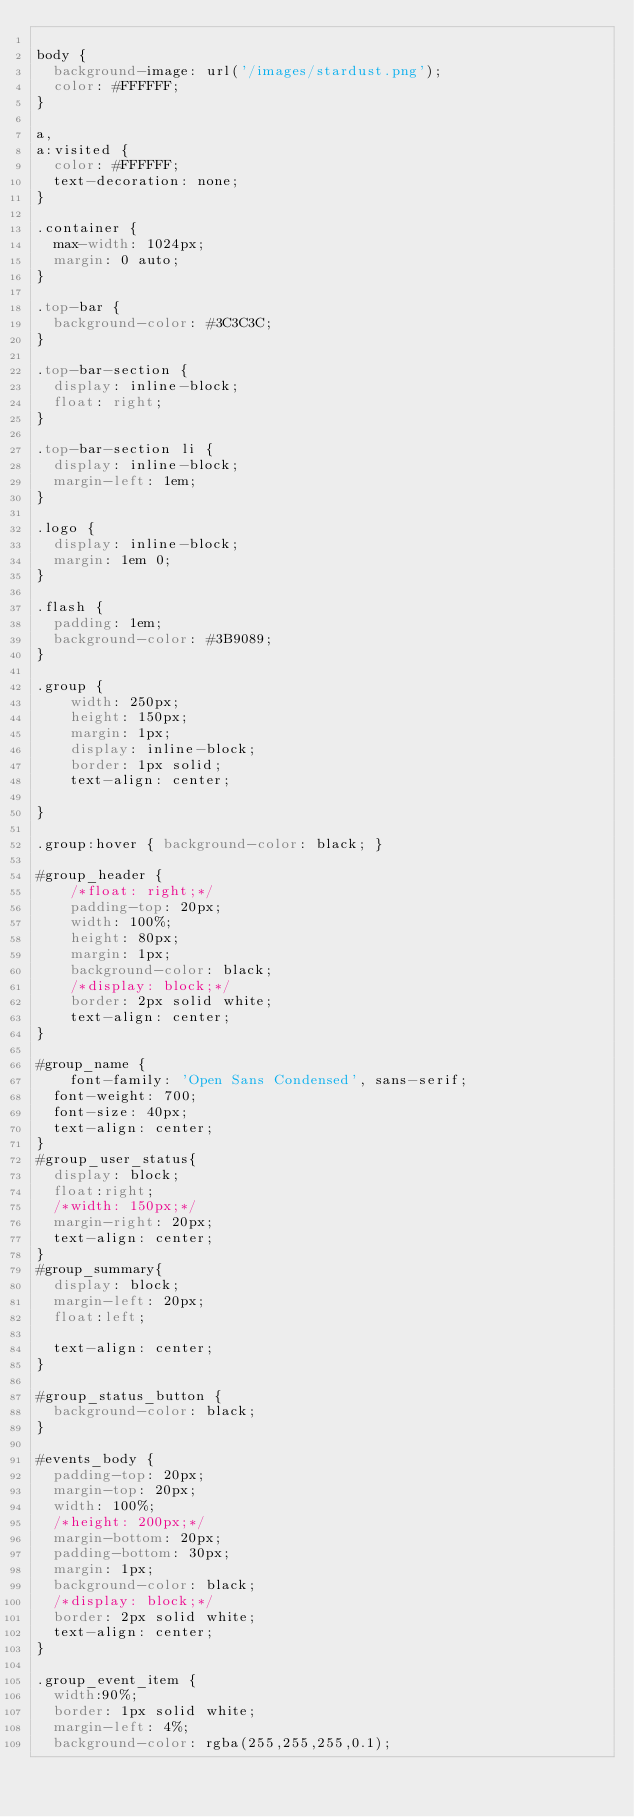<code> <loc_0><loc_0><loc_500><loc_500><_CSS_>
body {
  background-image: url('/images/stardust.png');
  color: #FFFFFF;
}

a,
a:visited {
  color: #FFFFFF;
  text-decoration: none;
}

.container {
  max-width: 1024px;
  margin: 0 auto;
}

.top-bar {
  background-color: #3C3C3C;
}

.top-bar-section {
  display: inline-block;
  float: right;
}

.top-bar-section li {
  display: inline-block;
  margin-left: 1em;
}

.logo {
  display: inline-block;
  margin: 1em 0;
}

.flash {
  padding: 1em;
  background-color: #3B9089;
}

.group {
    width: 250px;
    height: 150px;
    margin: 1px;
    display: inline-block;
    border: 1px solid;
    text-align: center;

}

.group:hover { background-color: black; }

#group_header {
    /*float: right;*/
    padding-top: 20px;
    width: 100%;
    height: 80px;
    margin: 1px;
    background-color: black;
    /*display: block;*/
    border: 2px solid white;
    text-align: center;
}

#group_name {
    font-family: 'Open Sans Condensed', sans-serif;
  font-weight: 700;
  font-size: 40px;
  text-align: center;
}
#group_user_status{
  display: block;
  float:right;
  /*width: 150px;*/
  margin-right: 20px;
  text-align: center;
}
#group_summary{
  display: block;
  margin-left: 20px;
  float:left;

  text-align: center;
}

#group_status_button {
  background-color: black;
}

#events_body {
  padding-top: 20px;
  margin-top: 20px;
  width: 100%;
  /*height: 200px;*/
  margin-bottom: 20px;
  padding-bottom: 30px;
  margin: 1px;
  background-color: black;
  /*display: block;*/
  border: 2px solid white;
  text-align: center;
}

.group_event_item {
  width:90%;
  border: 1px solid white;
  margin-left: 4%;
  background-color: rgba(255,255,255,0.1);</code> 